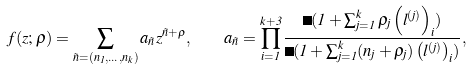Convert formula to latex. <formula><loc_0><loc_0><loc_500><loc_500>f ( z ; \rho ) = \sum _ { \vec { n } = ( n _ { 1 } , \dots , n _ { k } ) } a _ { \vec { n } } z ^ { \vec { n } + \rho } , \quad a _ { \vec { n } } = \prod _ { i = 1 } ^ { k + 3 } \frac { \Gamma ( 1 + \sum _ { j = 1 } ^ { k } \rho _ { j } \left ( l ^ { ( j ) } \right ) _ { i } ) } { \Gamma ( 1 + \sum _ { j = 1 } ^ { k } ( n _ { j } + \rho _ { j } ) \left ( l ^ { ( j ) } \right ) _ { i } ) } ,</formula> 